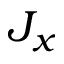<formula> <loc_0><loc_0><loc_500><loc_500>J _ { x }</formula> 